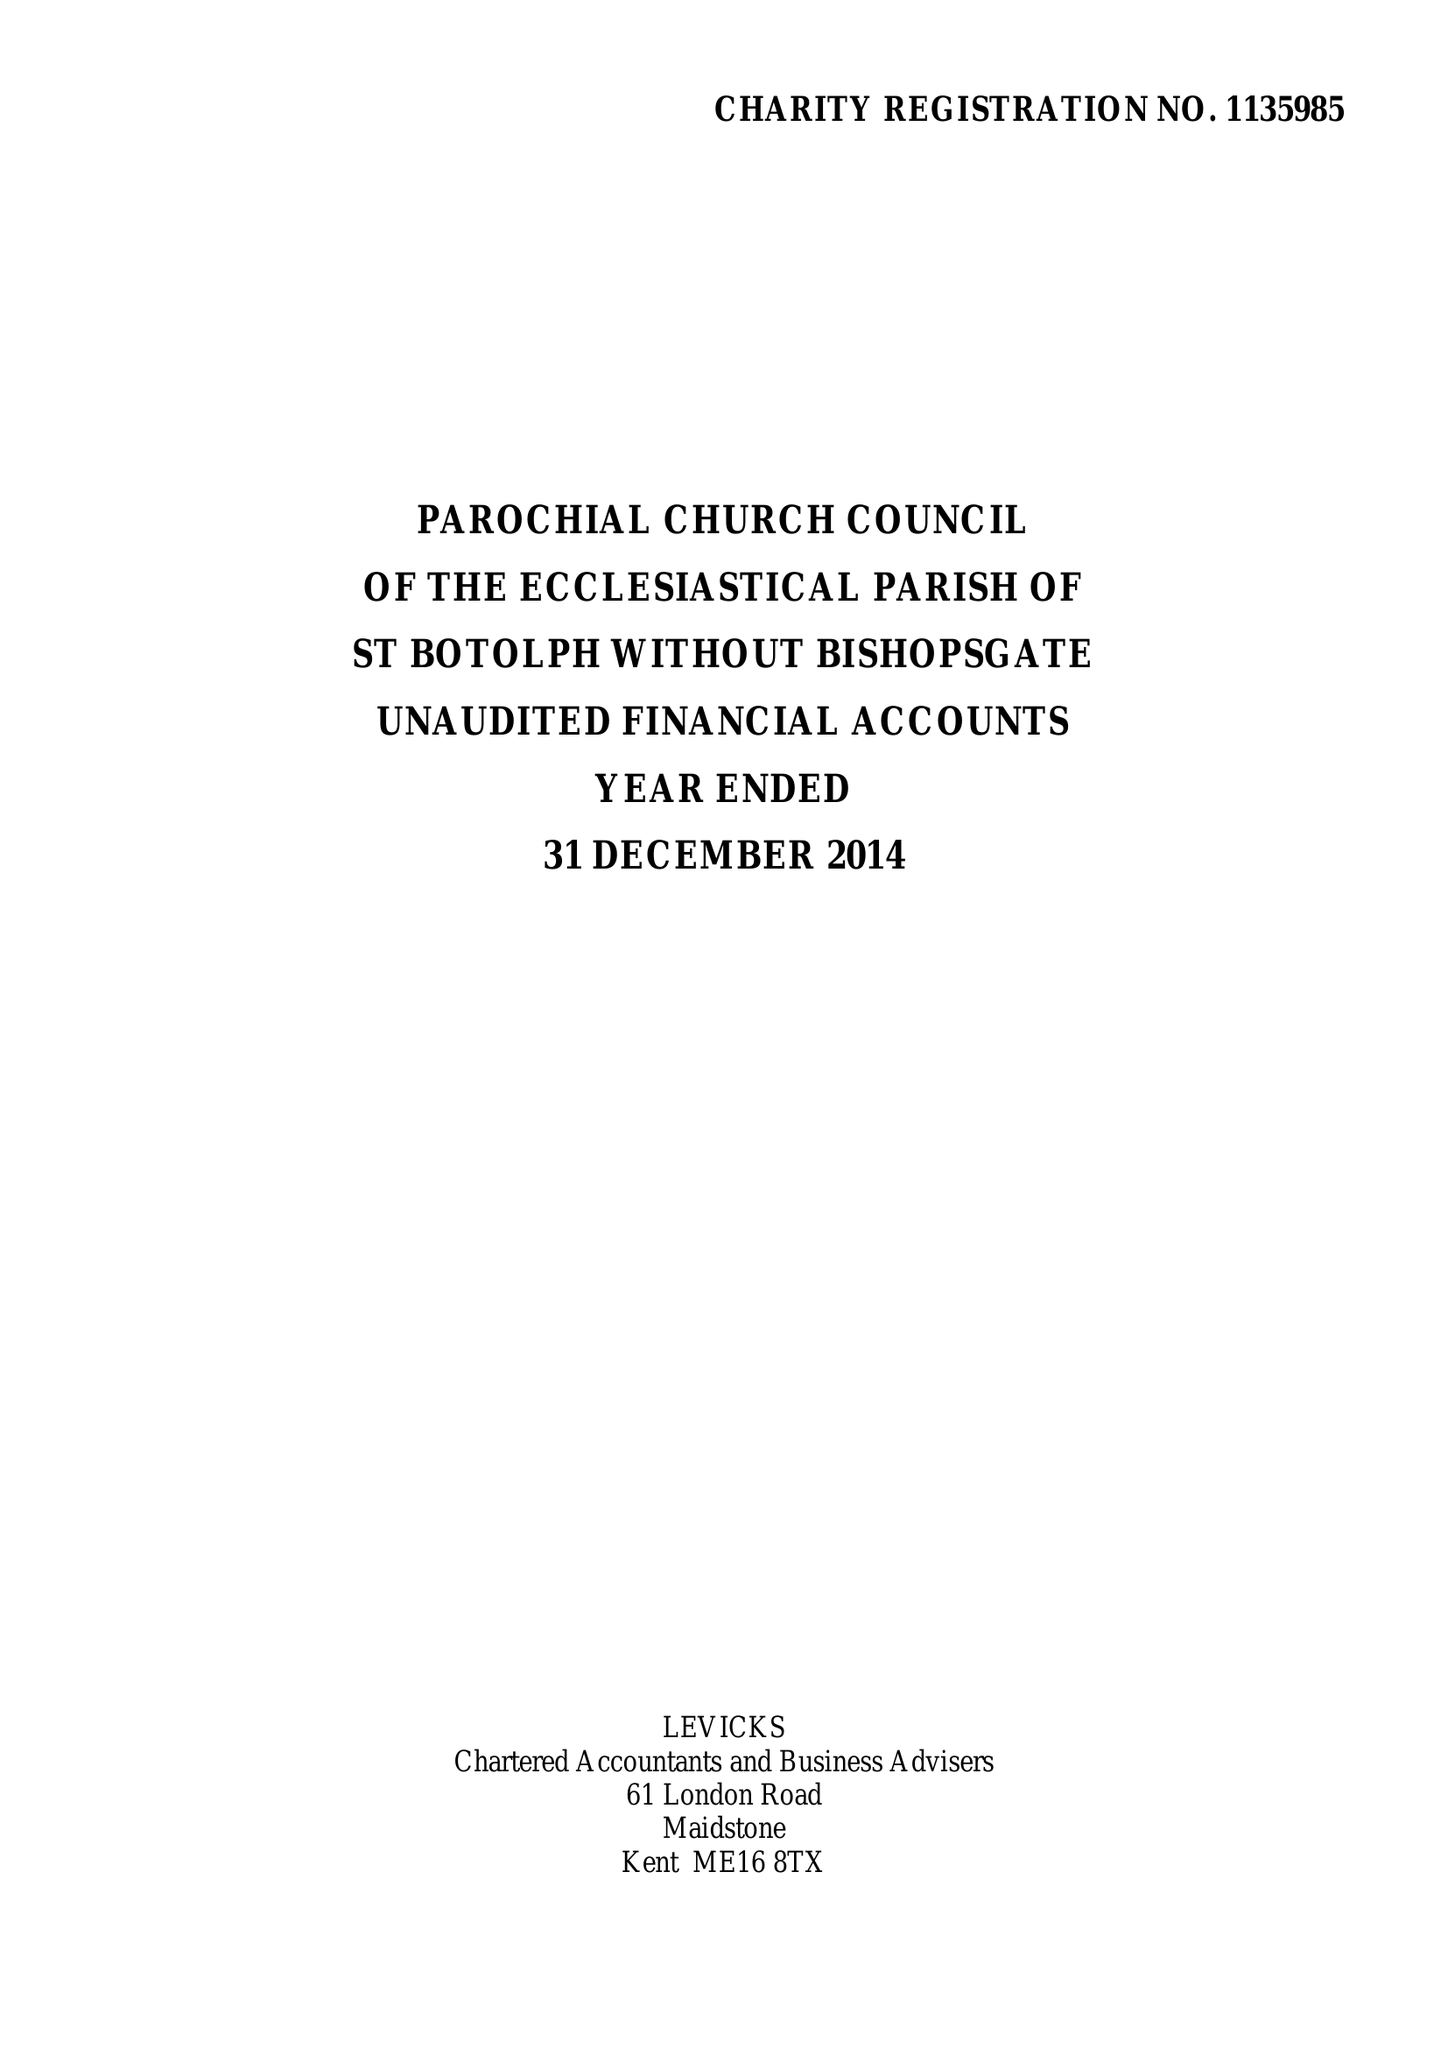What is the value for the charity_number?
Answer the question using a single word or phrase. 1135985 